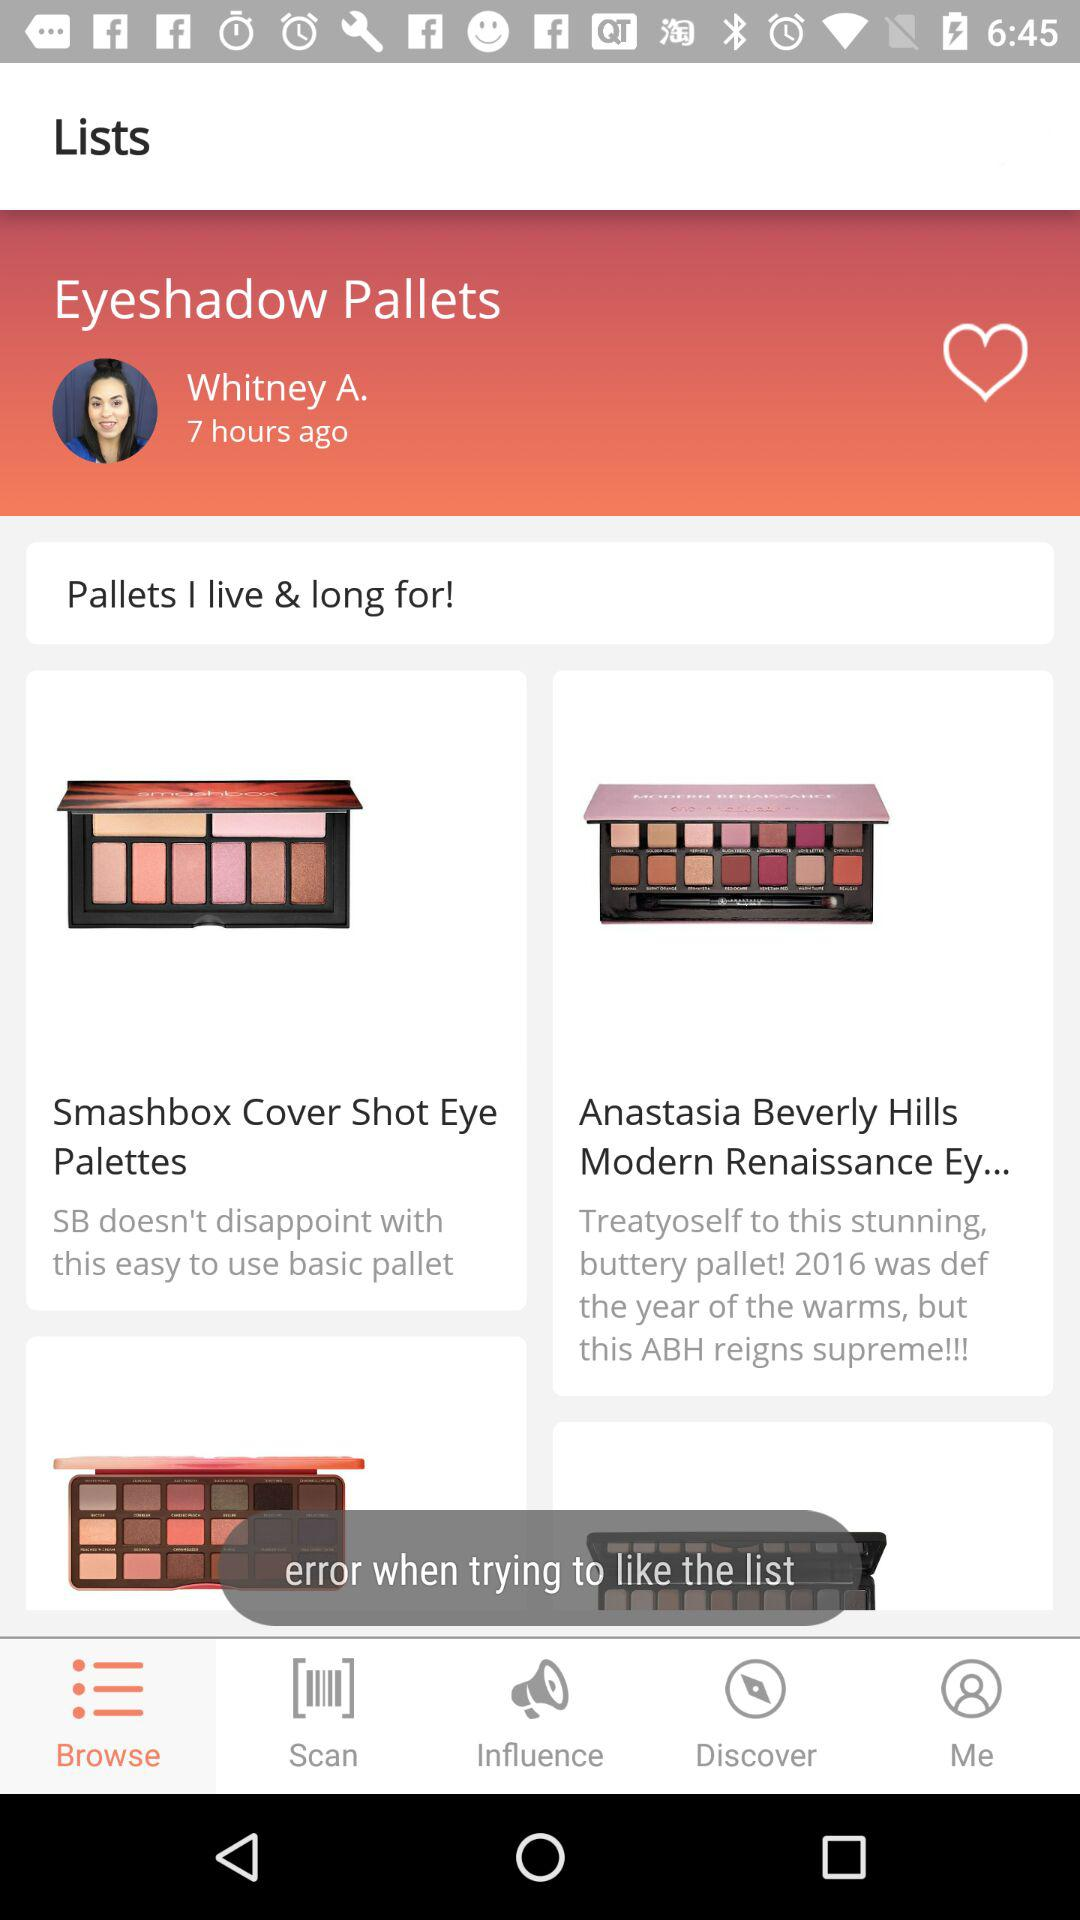Which tab is selected? The selected tab is "Browse". 